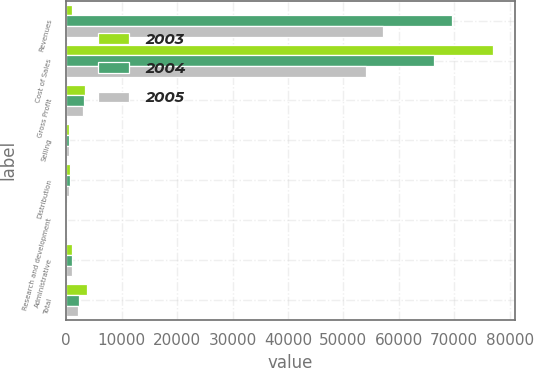<chart> <loc_0><loc_0><loc_500><loc_500><stacked_bar_chart><ecel><fcel>Revenues<fcel>Cost of Sales<fcel>Gross Profit<fcel>Selling<fcel>Distribution<fcel>Research and development<fcel>Administrative<fcel>Total<nl><fcel>2003<fcel>1047.1<fcel>77049.9<fcel>3464.7<fcel>550.1<fcel>676<fcel>182<fcel>1047.1<fcel>3655.2<nl><fcel>2004<fcel>69506.1<fcel>66257.9<fcel>3248.2<fcel>513.1<fcel>625.7<fcel>172.7<fcel>953.3<fcel>2264.8<nl><fcel>2005<fcel>57120.8<fcel>54018.3<fcel>3102.5<fcel>499<fcel>571.7<fcel>149.4<fcel>949.4<fcel>2169.5<nl></chart> 